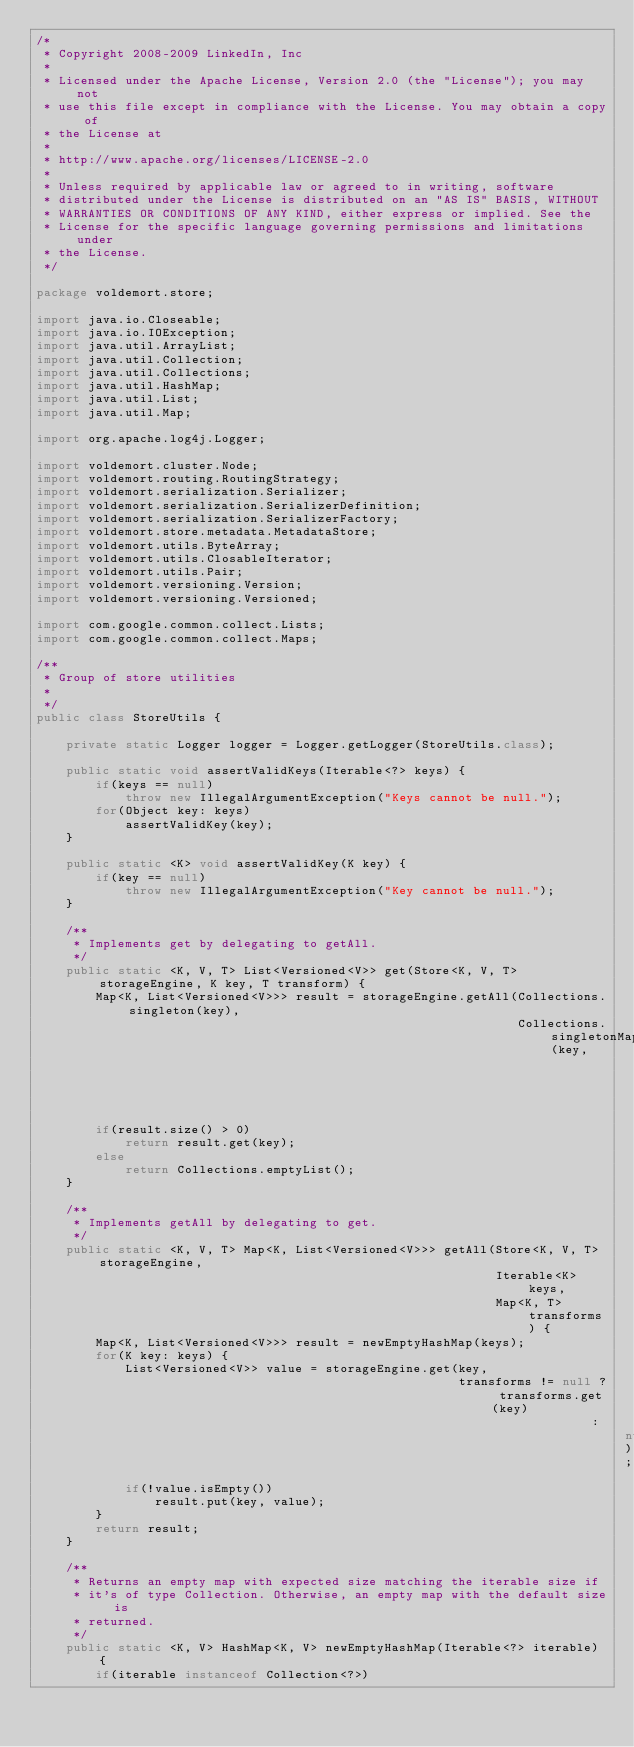Convert code to text. <code><loc_0><loc_0><loc_500><loc_500><_Java_>/*
 * Copyright 2008-2009 LinkedIn, Inc
 * 
 * Licensed under the Apache License, Version 2.0 (the "License"); you may not
 * use this file except in compliance with the License. You may obtain a copy of
 * the License at
 * 
 * http://www.apache.org/licenses/LICENSE-2.0
 * 
 * Unless required by applicable law or agreed to in writing, software
 * distributed under the License is distributed on an "AS IS" BASIS, WITHOUT
 * WARRANTIES OR CONDITIONS OF ANY KIND, either express or implied. See the
 * License for the specific language governing permissions and limitations under
 * the License.
 */

package voldemort.store;

import java.io.Closeable;
import java.io.IOException;
import java.util.ArrayList;
import java.util.Collection;
import java.util.Collections;
import java.util.HashMap;
import java.util.List;
import java.util.Map;

import org.apache.log4j.Logger;

import voldemort.cluster.Node;
import voldemort.routing.RoutingStrategy;
import voldemort.serialization.Serializer;
import voldemort.serialization.SerializerDefinition;
import voldemort.serialization.SerializerFactory;
import voldemort.store.metadata.MetadataStore;
import voldemort.utils.ByteArray;
import voldemort.utils.ClosableIterator;
import voldemort.utils.Pair;
import voldemort.versioning.Version;
import voldemort.versioning.Versioned;

import com.google.common.collect.Lists;
import com.google.common.collect.Maps;

/**
 * Group of store utilities
 * 
 */
public class StoreUtils {

    private static Logger logger = Logger.getLogger(StoreUtils.class);

    public static void assertValidKeys(Iterable<?> keys) {
        if(keys == null)
            throw new IllegalArgumentException("Keys cannot be null.");
        for(Object key: keys)
            assertValidKey(key);
    }

    public static <K> void assertValidKey(K key) {
        if(key == null)
            throw new IllegalArgumentException("Key cannot be null.");
    }

    /**
     * Implements get by delegating to getAll.
     */
    public static <K, V, T> List<Versioned<V>> get(Store<K, V, T> storageEngine, K key, T transform) {
        Map<K, List<Versioned<V>>> result = storageEngine.getAll(Collections.singleton(key),
                                                                 Collections.singletonMap(key,
                                                                                          transform));
        if(result.size() > 0)
            return result.get(key);
        else
            return Collections.emptyList();
    }

    /**
     * Implements getAll by delegating to get.
     */
    public static <K, V, T> Map<K, List<Versioned<V>>> getAll(Store<K, V, T> storageEngine,
                                                              Iterable<K> keys,
                                                              Map<K, T> transforms) {
        Map<K, List<Versioned<V>>> result = newEmptyHashMap(keys);
        for(K key: keys) {
            List<Versioned<V>> value = storageEngine.get(key,
                                                         transforms != null ? transforms.get(key)
                                                                           : null);
            if(!value.isEmpty())
                result.put(key, value);
        }
        return result;
    }

    /**
     * Returns an empty map with expected size matching the iterable size if
     * it's of type Collection. Otherwise, an empty map with the default size is
     * returned.
     */
    public static <K, V> HashMap<K, V> newEmptyHashMap(Iterable<?> iterable) {
        if(iterable instanceof Collection<?>)</code> 